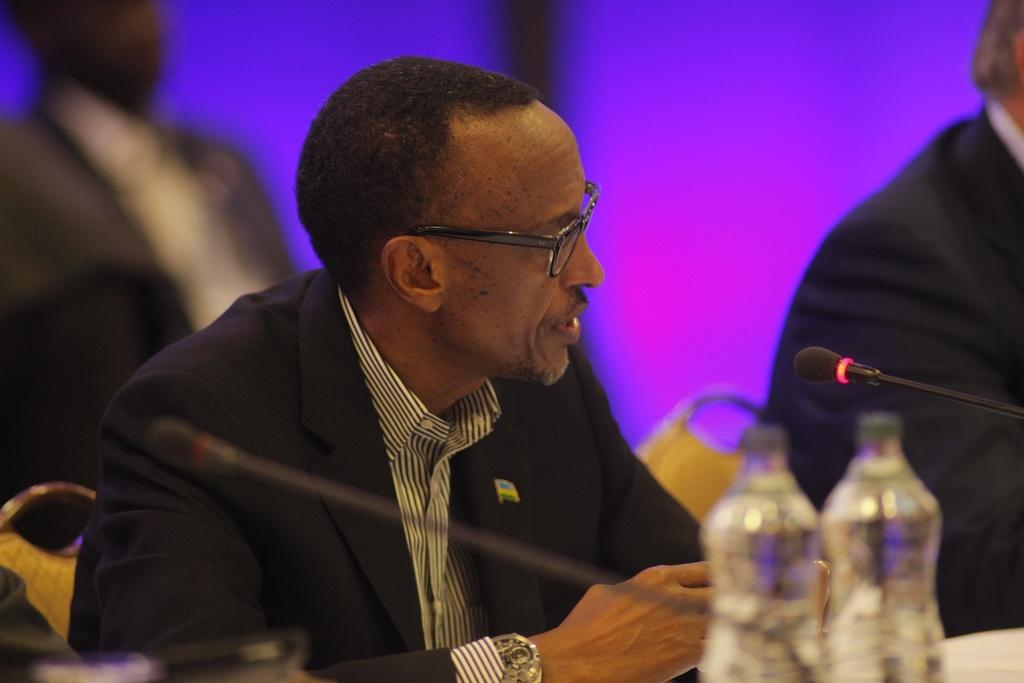What is happening in the image involving the group of people? The people are seated on chairs in the image. What object is in front of the people? There is a microphone in front of the people. What can be seen on the table in the image? There are bottles on the table. What type of ray is visible in the image? There is no ray present in the image. How does the memory of the group of people affect their discussion in the image? The image does not depict a discussion, nor does it provide information about the group's memory. 